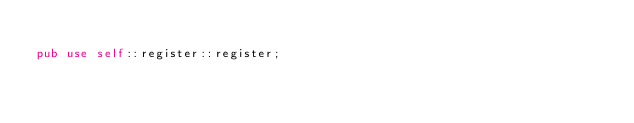<code> <loc_0><loc_0><loc_500><loc_500><_Rust_>
pub use self::register::register;
</code> 